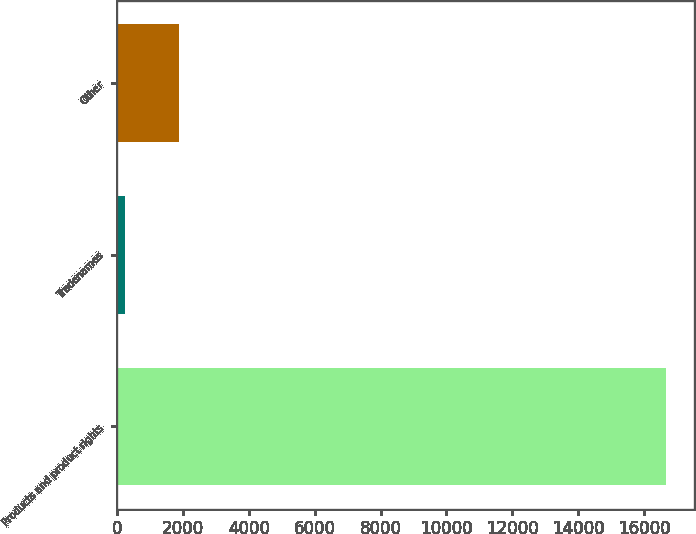Convert chart. <chart><loc_0><loc_0><loc_500><loc_500><bar_chart><fcel>Products and product rights<fcel>Tradenames<fcel>Other<nl><fcel>16678<fcel>236<fcel>1880.2<nl></chart> 